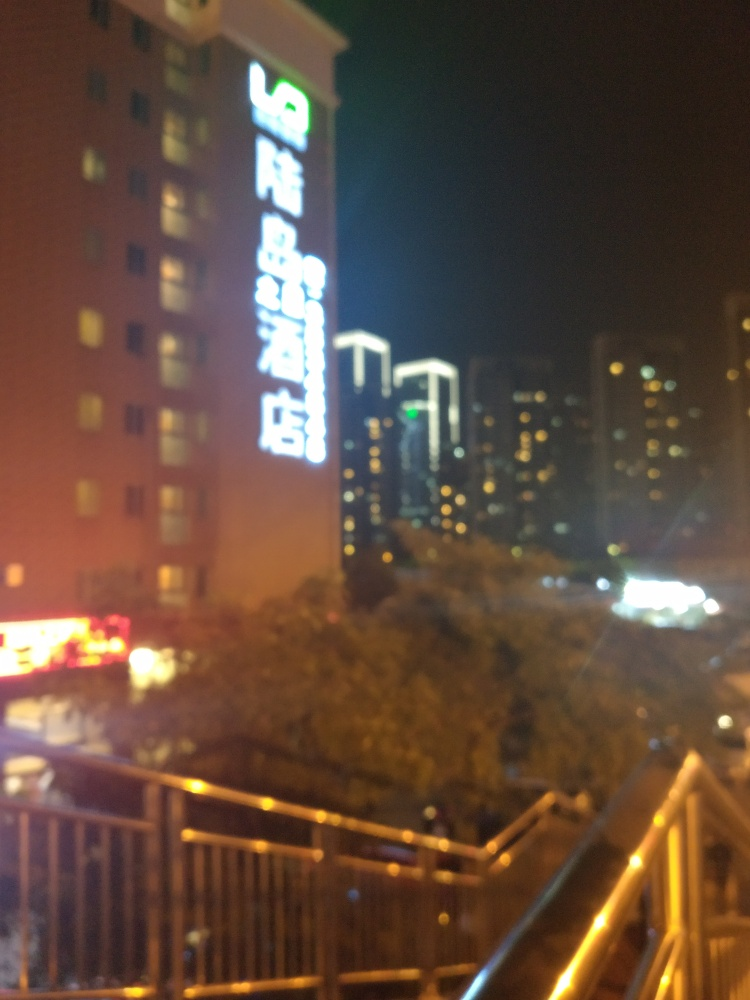What suggestions would you have for taking a better picture in similar conditions? To improve the quality of a night photo like this, use a steady hand or a tripod to prevent motion blur, ensure the camera is focused properly on the intended subject, and, if possible, adjust the camera settings for low-light conditions, such as increasing the ISO or using a slower shutter speed. 